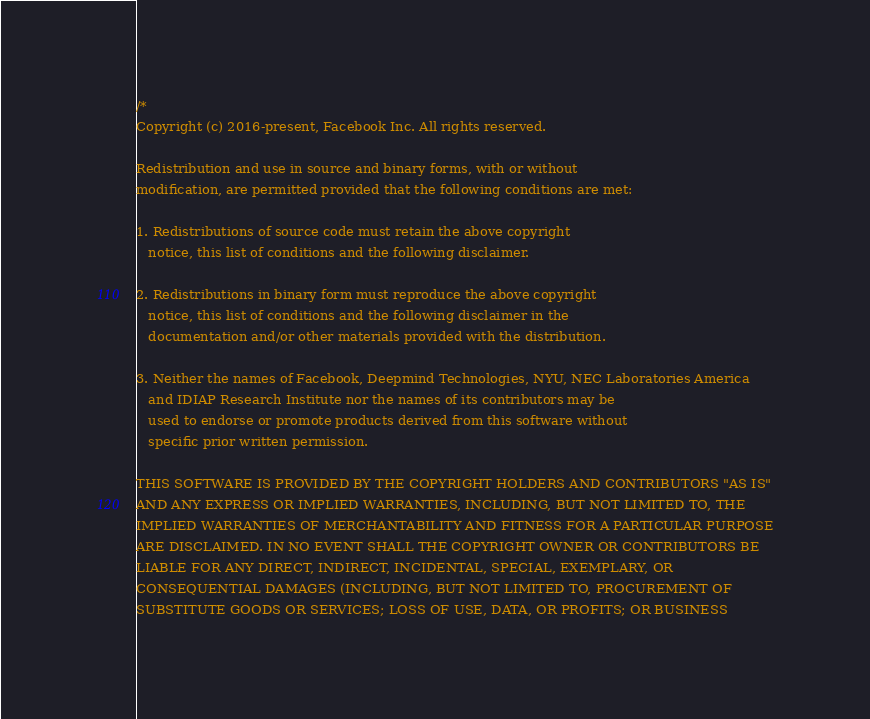<code> <loc_0><loc_0><loc_500><loc_500><_Cuda_>/*
Copyright (c) 2016-present, Facebook Inc. All rights reserved.

Redistribution and use in source and binary forms, with or without
modification, are permitted provided that the following conditions are met:

1. Redistributions of source code must retain the above copyright
   notice, this list of conditions and the following disclaimer.

2. Redistributions in binary form must reproduce the above copyright
   notice, this list of conditions and the following disclaimer in the
   documentation and/or other materials provided with the distribution.

3. Neither the names of Facebook, Deepmind Technologies, NYU, NEC Laboratories America
   and IDIAP Research Institute nor the names of its contributors may be
   used to endorse or promote products derived from this software without
   specific prior written permission.

THIS SOFTWARE IS PROVIDED BY THE COPYRIGHT HOLDERS AND CONTRIBUTORS "AS IS"
AND ANY EXPRESS OR IMPLIED WARRANTIES, INCLUDING, BUT NOT LIMITED TO, THE
IMPLIED WARRANTIES OF MERCHANTABILITY AND FITNESS FOR A PARTICULAR PURPOSE
ARE DISCLAIMED. IN NO EVENT SHALL THE COPYRIGHT OWNER OR CONTRIBUTORS BE
LIABLE FOR ANY DIRECT, INDIRECT, INCIDENTAL, SPECIAL, EXEMPLARY, OR
CONSEQUENTIAL DAMAGES (INCLUDING, BUT NOT LIMITED TO, PROCUREMENT OF
SUBSTITUTE GOODS OR SERVICES; LOSS OF USE, DATA, OR PROFITS; OR BUSINESS</code> 